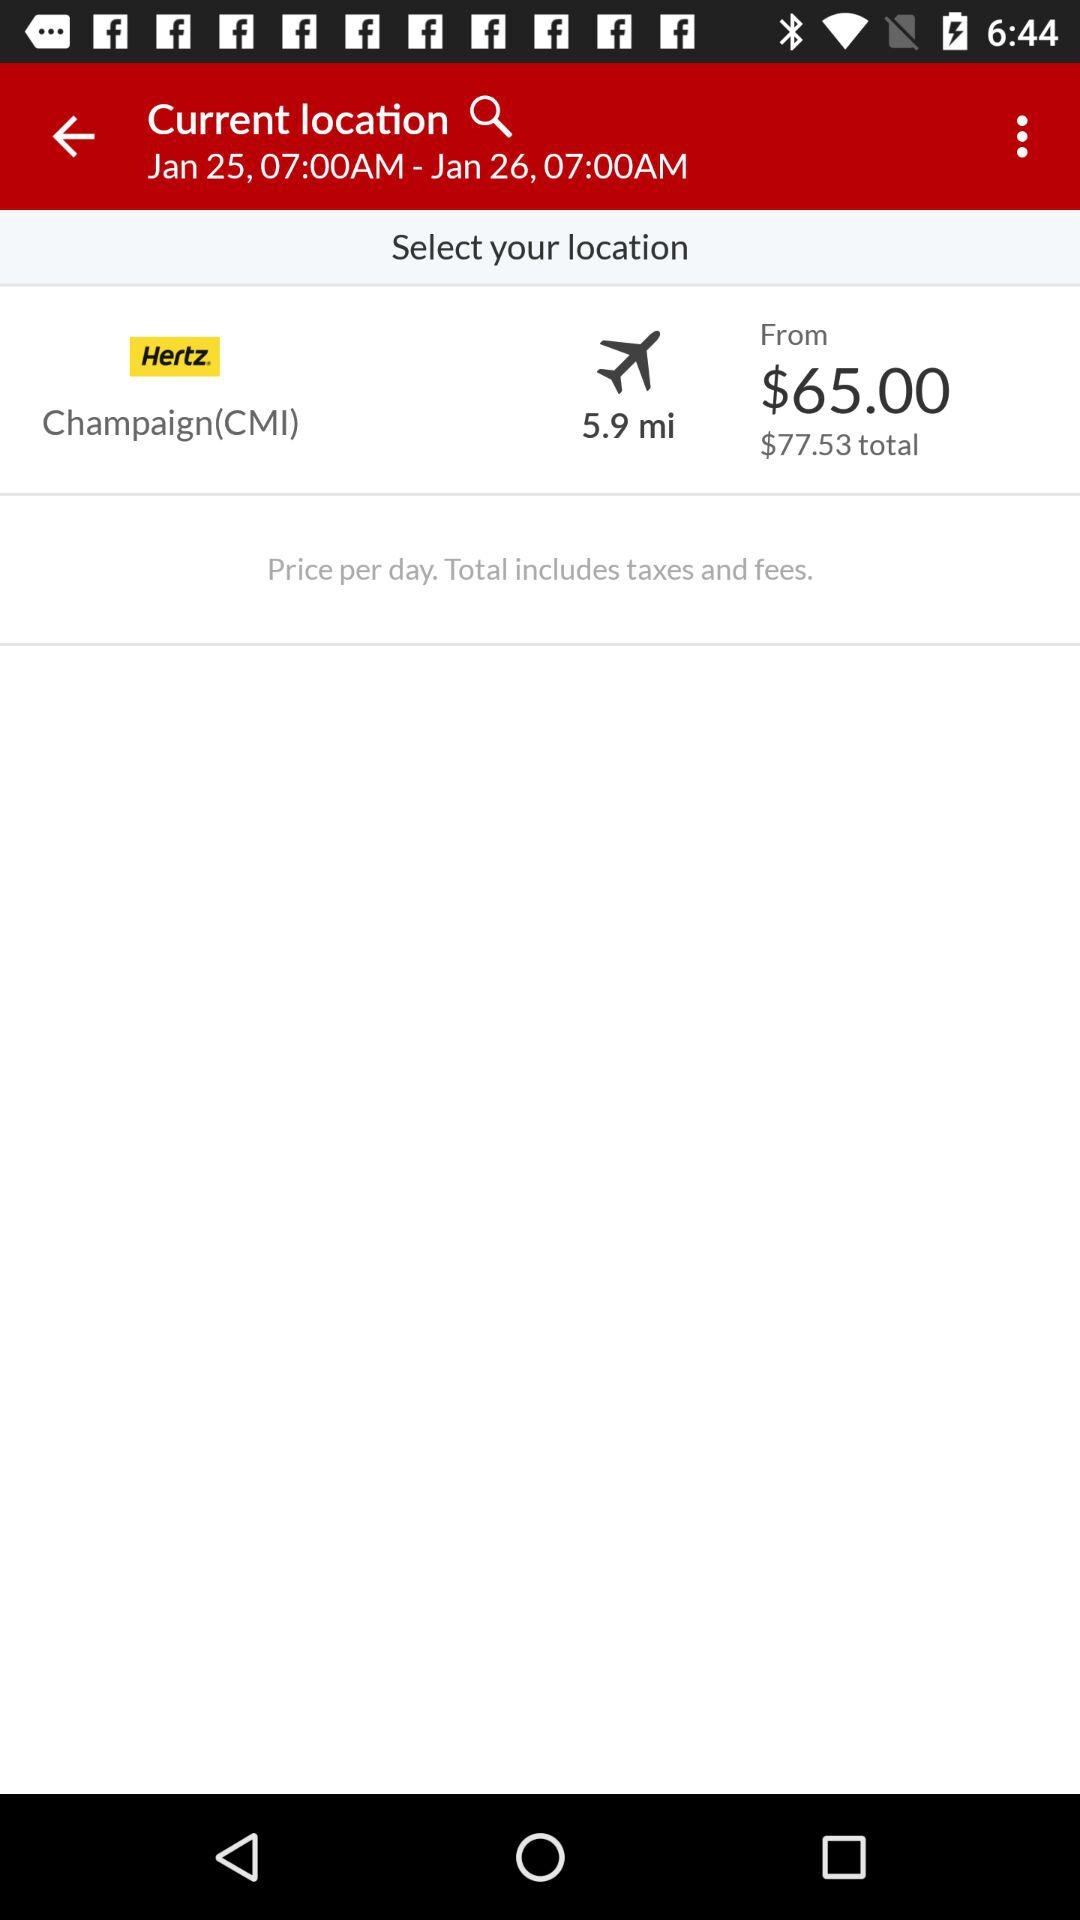How much more expensive is the total price than the from price?
Answer the question using a single word or phrase. $12.53 